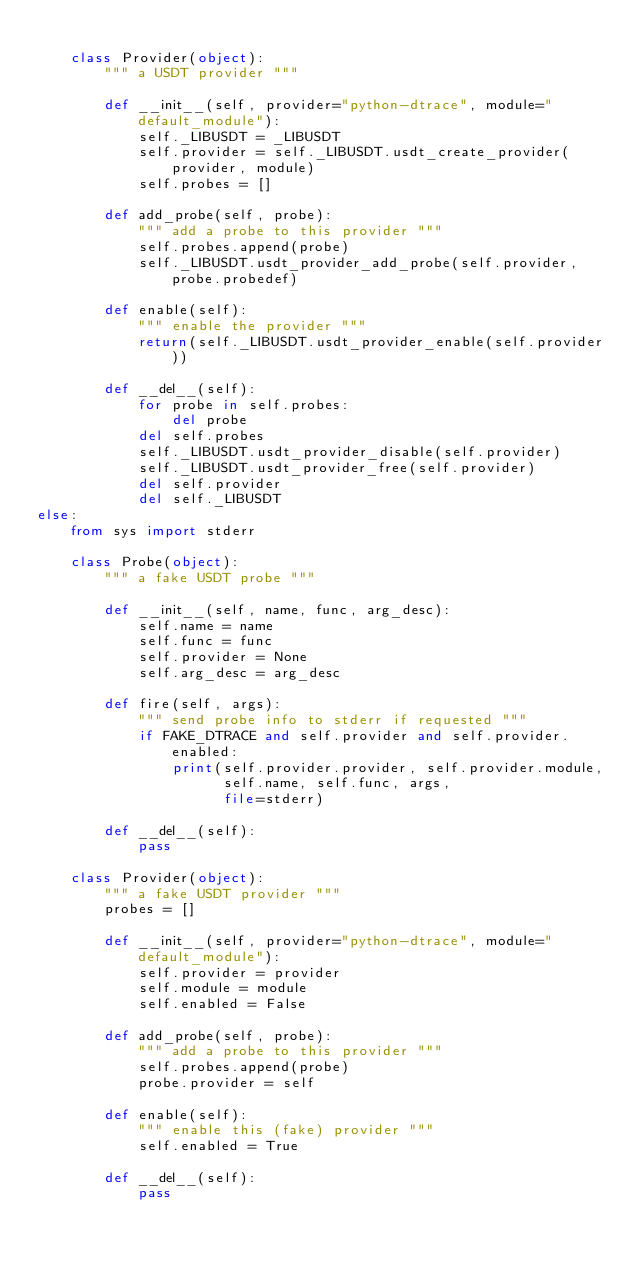<code> <loc_0><loc_0><loc_500><loc_500><_Python_>
    class Provider(object):
        """ a USDT provider """

        def __init__(self, provider="python-dtrace", module="default_module"):
            self._LIBUSDT = _LIBUSDT
            self.provider = self._LIBUSDT.usdt_create_provider(provider, module)
            self.probes = []

        def add_probe(self, probe):
            """ add a probe to this provider """
            self.probes.append(probe)
            self._LIBUSDT.usdt_provider_add_probe(self.provider, probe.probedef)

        def enable(self):
            """ enable the provider """
            return(self._LIBUSDT.usdt_provider_enable(self.provider))

        def __del__(self):
            for probe in self.probes:
                del probe
            del self.probes
            self._LIBUSDT.usdt_provider_disable(self.provider)
            self._LIBUSDT.usdt_provider_free(self.provider)
            del self.provider
            del self._LIBUSDT
else:
    from sys import stderr

    class Probe(object):
        """ a fake USDT probe """

        def __init__(self, name, func, arg_desc):
            self.name = name
            self.func = func
            self.provider = None
            self.arg_desc = arg_desc

        def fire(self, args):
            """ send probe info to stderr if requested """
            if FAKE_DTRACE and self.provider and self.provider.enabled:
                print(self.provider.provider, self.provider.module,
                      self.name, self.func, args,
                      file=stderr)

        def __del__(self):
            pass

    class Provider(object):
        """ a fake USDT provider """
        probes = []

        def __init__(self, provider="python-dtrace", module="default_module"):
            self.provider = provider
            self.module = module
            self.enabled = False

        def add_probe(self, probe):
            """ add a probe to this provider """
            self.probes.append(probe)
            probe.provider = self

        def enable(self):
            """ enable this (fake) provider """
            self.enabled = True

        def __del__(self):
            pass
</code> 